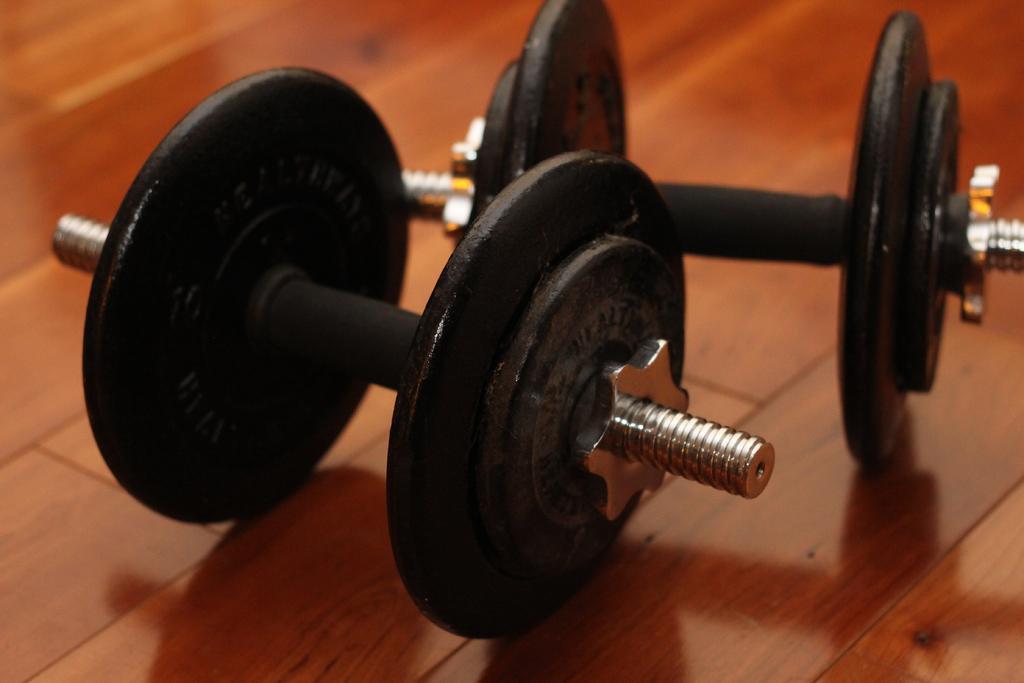Describe this image in one or two sentences. In this image we can see a pair of dumbbells on the floor. 